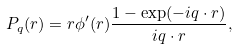<formula> <loc_0><loc_0><loc_500><loc_500>P _ { q } ( { r } ) = r \phi ^ { \prime } ( r ) \frac { 1 - \exp ( - i { q } \cdot { r } ) } { i { q } \cdot { r } } ,</formula> 